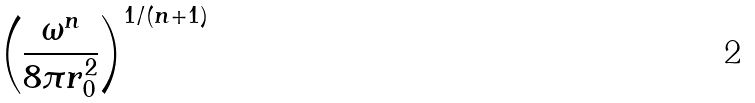<formula> <loc_0><loc_0><loc_500><loc_500>\left ( \frac { \omega ^ { n } } { 8 \pi r _ { 0 } ^ { 2 } } \right ) ^ { 1 / ( n + 1 ) }</formula> 